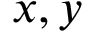Convert formula to latex. <formula><loc_0><loc_0><loc_500><loc_500>x , y</formula> 